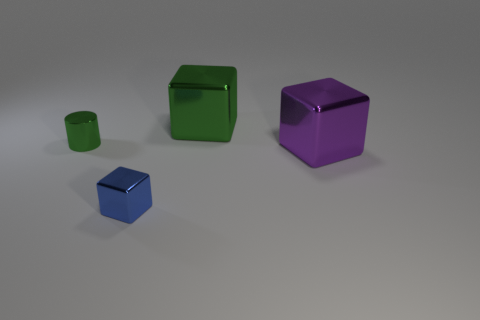What is the material of the big green object?
Your answer should be compact. Metal. How many metal things are either spheres or small blue objects?
Offer a very short reply. 1. There is a metallic thing that is right of the green shiny cube; what shape is it?
Offer a very short reply. Cube. There is a purple thing that is the same material as the green cylinder; what size is it?
Offer a very short reply. Large. What shape is the thing that is both behind the purple thing and to the right of the green metallic cylinder?
Your response must be concise. Cube. Does the metallic thing that is behind the green cylinder have the same color as the cylinder?
Your answer should be very brief. Yes. Is the shape of the small green thing that is left of the green block the same as the metallic object that is on the right side of the large green metallic object?
Give a very brief answer. No. How big is the thing that is behind the small green cylinder?
Ensure brevity in your answer.  Large. What is the size of the block on the right side of the block behind the small shiny cylinder?
Offer a terse response. Large. Are there more cylinders than big red cubes?
Make the answer very short. Yes. 